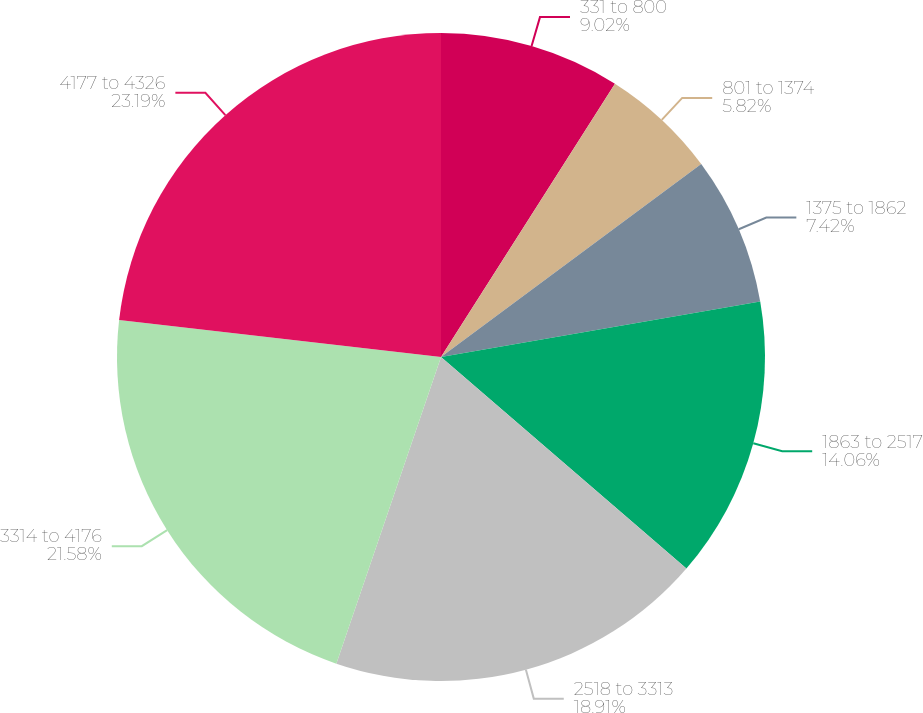<chart> <loc_0><loc_0><loc_500><loc_500><pie_chart><fcel>331 to 800<fcel>801 to 1374<fcel>1375 to 1862<fcel>1863 to 2517<fcel>2518 to 3313<fcel>3314 to 4176<fcel>4177 to 4326<nl><fcel>9.02%<fcel>5.82%<fcel>7.42%<fcel>14.06%<fcel>18.91%<fcel>21.58%<fcel>23.18%<nl></chart> 